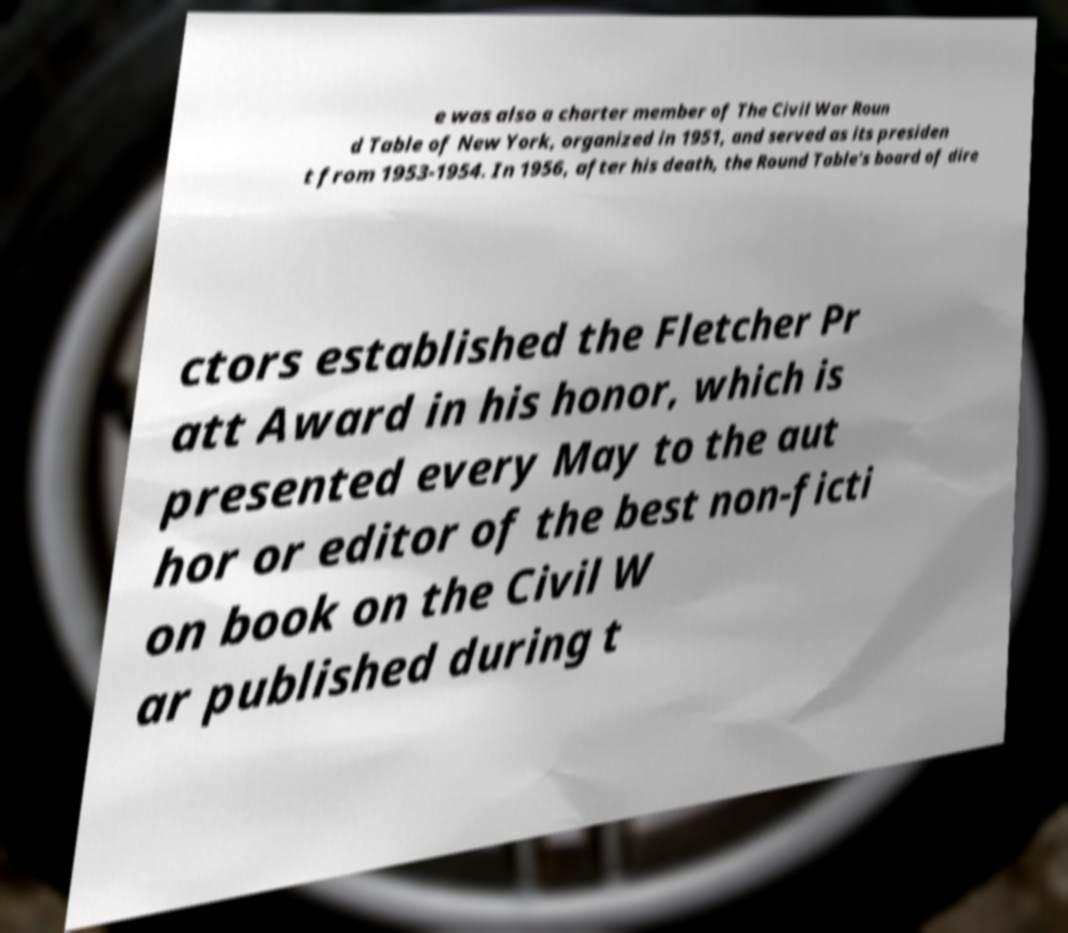Can you read and provide the text displayed in the image?This photo seems to have some interesting text. Can you extract and type it out for me? e was also a charter member of The Civil War Roun d Table of New York, organized in 1951, and served as its presiden t from 1953-1954. In 1956, after his death, the Round Table's board of dire ctors established the Fletcher Pr att Award in his honor, which is presented every May to the aut hor or editor of the best non-ficti on book on the Civil W ar published during t 